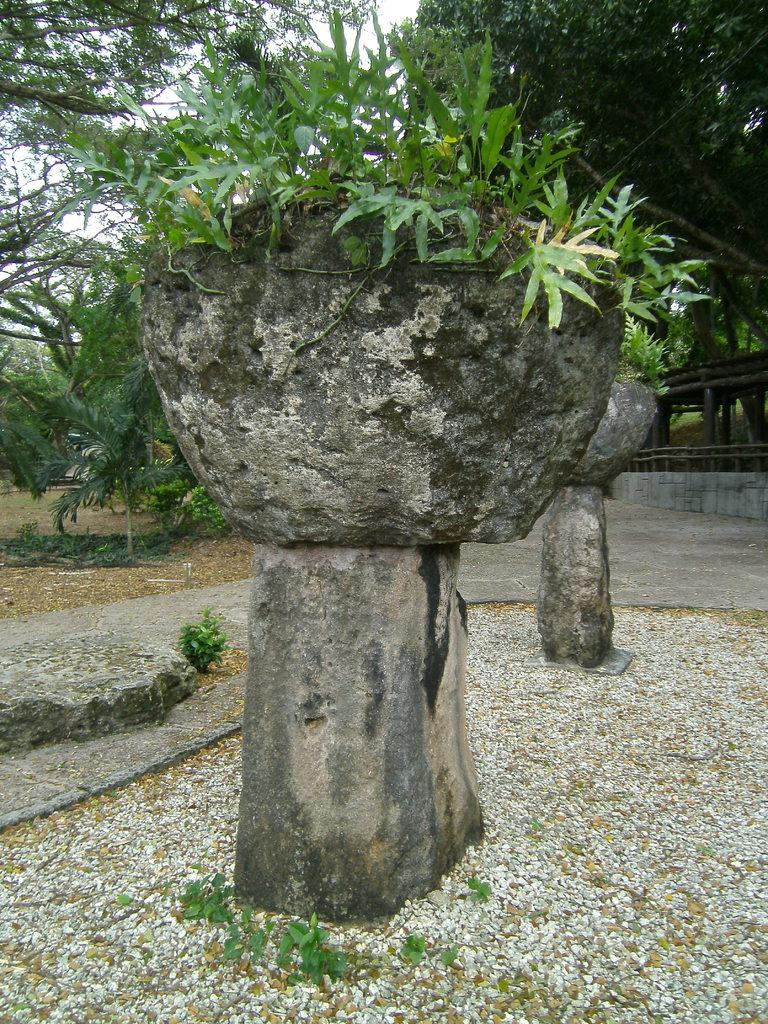What is located on the pillar in the image? There are plant pots on a pillar in the image. What type of vegetation is near the plant pots? There are trees beside the plant pots in the image. What type of leather is being used to make the fish swim in the image? There is no fish or leather present in the image; it features plant pots on a pillar and trees beside them. 